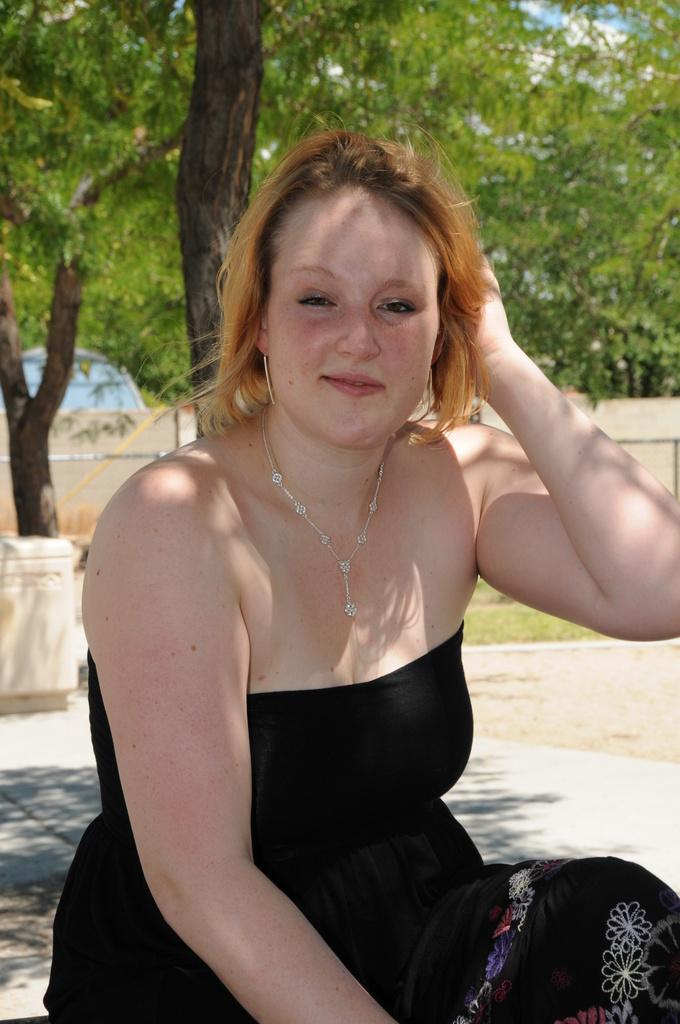What is the person in the image doing? The person is sitting on the ground in the image. What can be seen in the background of the image? There are trees, grass, a vehicle, a wall, and a box in the background of the image. What flavor of card is the person holding in the image? There is no card present in the image, and therefore no flavor can be determined. 